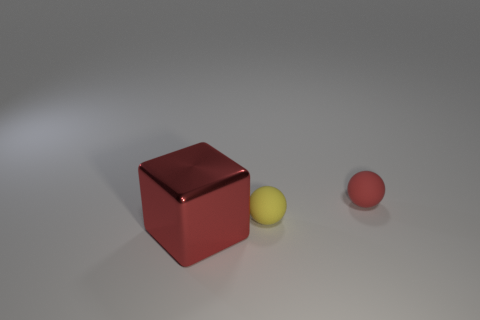Are there any objects made of the same material as the yellow sphere?
Provide a short and direct response. Yes. There is a rubber thing that is the same color as the large cube; what size is it?
Your response must be concise. Small. What number of balls are either tiny red matte things or small matte things?
Provide a short and direct response. 2. Is the number of yellow things on the right side of the red ball greater than the number of big red blocks in front of the red block?
Provide a short and direct response. No. How many other blocks are the same color as the big block?
Your answer should be compact. 0. How many things are small rubber balls that are on the right side of the yellow ball or large cyan matte balls?
Make the answer very short. 1. Does the sphere that is on the right side of the small yellow matte sphere have the same color as the large shiny cube?
Provide a short and direct response. Yes. What color is the tiny matte thing in front of the red object behind the red thing in front of the tiny yellow matte thing?
Your answer should be compact. Yellow. Do the large block and the yellow object have the same material?
Give a very brief answer. No. There is a tiny sphere behind the small thing in front of the tiny red matte ball; are there any big red cubes that are behind it?
Offer a terse response. No. 